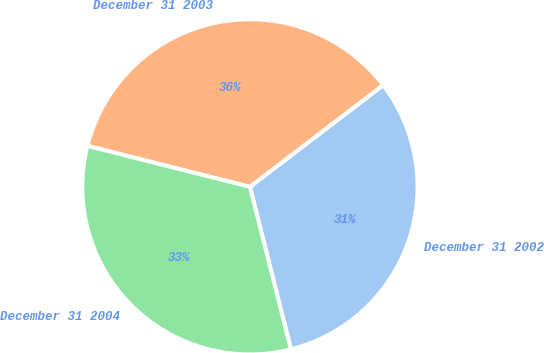Convert chart. <chart><loc_0><loc_0><loc_500><loc_500><pie_chart><fcel>December 31 2002<fcel>December 31 2003<fcel>December 31 2004<nl><fcel>31.44%<fcel>35.69%<fcel>32.86%<nl></chart> 